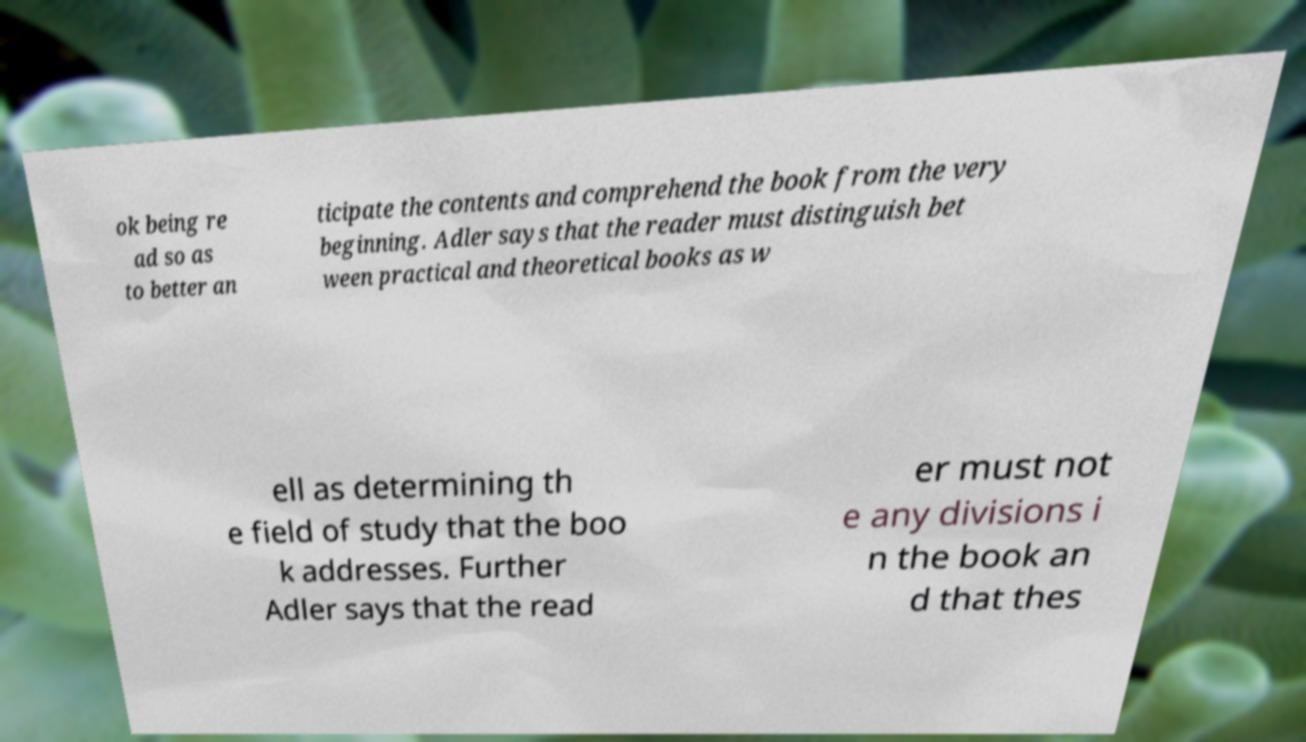Can you accurately transcribe the text from the provided image for me? ok being re ad so as to better an ticipate the contents and comprehend the book from the very beginning. Adler says that the reader must distinguish bet ween practical and theoretical books as w ell as determining th e field of study that the boo k addresses. Further Adler says that the read er must not e any divisions i n the book an d that thes 